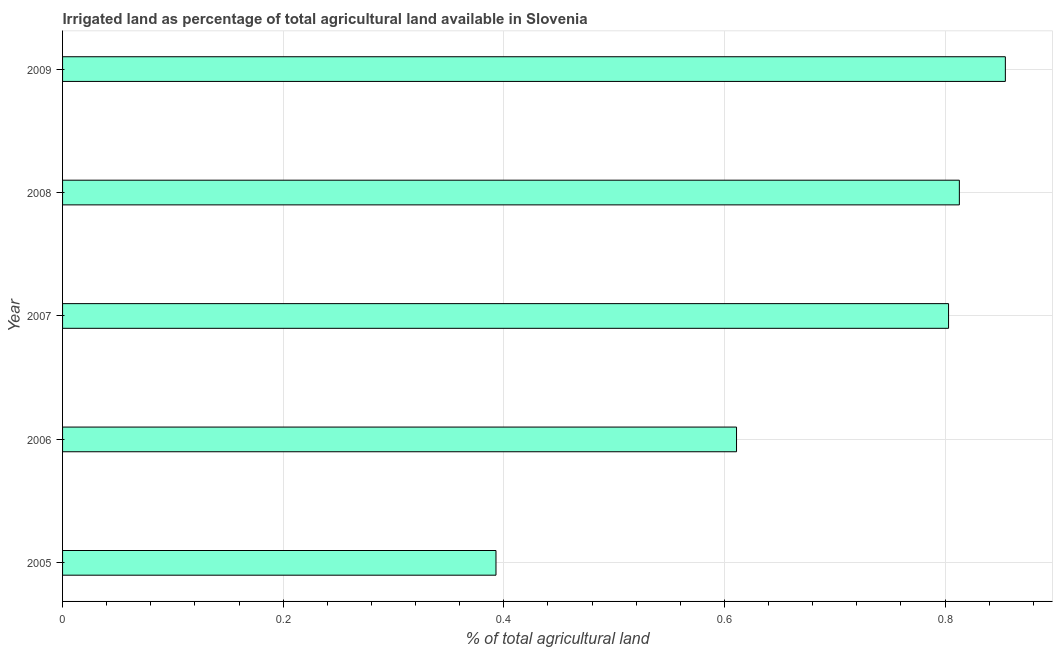Does the graph contain grids?
Your answer should be very brief. Yes. What is the title of the graph?
Offer a terse response. Irrigated land as percentage of total agricultural land available in Slovenia. What is the label or title of the X-axis?
Keep it short and to the point. % of total agricultural land. What is the percentage of agricultural irrigated land in 2009?
Your response must be concise. 0.85. Across all years, what is the maximum percentage of agricultural irrigated land?
Ensure brevity in your answer.  0.85. Across all years, what is the minimum percentage of agricultural irrigated land?
Make the answer very short. 0.39. In which year was the percentage of agricultural irrigated land minimum?
Offer a terse response. 2005. What is the sum of the percentage of agricultural irrigated land?
Your response must be concise. 3.47. What is the difference between the percentage of agricultural irrigated land in 2007 and 2009?
Your answer should be compact. -0.05. What is the average percentage of agricultural irrigated land per year?
Offer a terse response. 0.69. What is the median percentage of agricultural irrigated land?
Your answer should be compact. 0.8. In how many years, is the percentage of agricultural irrigated land greater than 0.48 %?
Provide a succinct answer. 4. Do a majority of the years between 2007 and 2005 (inclusive) have percentage of agricultural irrigated land greater than 0.32 %?
Offer a very short reply. Yes. Is the difference between the percentage of agricultural irrigated land in 2007 and 2009 greater than the difference between any two years?
Provide a succinct answer. No. What is the difference between the highest and the second highest percentage of agricultural irrigated land?
Keep it short and to the point. 0.04. What is the difference between the highest and the lowest percentage of agricultural irrigated land?
Make the answer very short. 0.46. In how many years, is the percentage of agricultural irrigated land greater than the average percentage of agricultural irrigated land taken over all years?
Offer a terse response. 3. How many years are there in the graph?
Offer a very short reply. 5. What is the % of total agricultural land in 2005?
Ensure brevity in your answer.  0.39. What is the % of total agricultural land of 2006?
Provide a short and direct response. 0.61. What is the % of total agricultural land in 2007?
Give a very brief answer. 0.8. What is the % of total agricultural land in 2008?
Your answer should be very brief. 0.81. What is the % of total agricultural land of 2009?
Your answer should be compact. 0.85. What is the difference between the % of total agricultural land in 2005 and 2006?
Your answer should be very brief. -0.22. What is the difference between the % of total agricultural land in 2005 and 2007?
Keep it short and to the point. -0.41. What is the difference between the % of total agricultural land in 2005 and 2008?
Provide a short and direct response. -0.42. What is the difference between the % of total agricultural land in 2005 and 2009?
Your answer should be compact. -0.46. What is the difference between the % of total agricultural land in 2006 and 2007?
Give a very brief answer. -0.19. What is the difference between the % of total agricultural land in 2006 and 2008?
Keep it short and to the point. -0.2. What is the difference between the % of total agricultural land in 2006 and 2009?
Your response must be concise. -0.24. What is the difference between the % of total agricultural land in 2007 and 2008?
Your answer should be compact. -0.01. What is the difference between the % of total agricultural land in 2007 and 2009?
Make the answer very short. -0.05. What is the difference between the % of total agricultural land in 2008 and 2009?
Your answer should be very brief. -0.04. What is the ratio of the % of total agricultural land in 2005 to that in 2006?
Provide a short and direct response. 0.64. What is the ratio of the % of total agricultural land in 2005 to that in 2007?
Ensure brevity in your answer.  0.49. What is the ratio of the % of total agricultural land in 2005 to that in 2008?
Provide a succinct answer. 0.48. What is the ratio of the % of total agricultural land in 2005 to that in 2009?
Provide a short and direct response. 0.46. What is the ratio of the % of total agricultural land in 2006 to that in 2007?
Your answer should be very brief. 0.76. What is the ratio of the % of total agricultural land in 2006 to that in 2008?
Keep it short and to the point. 0.75. What is the ratio of the % of total agricultural land in 2006 to that in 2009?
Your response must be concise. 0.71. What is the ratio of the % of total agricultural land in 2007 to that in 2008?
Your answer should be compact. 0.99. What is the ratio of the % of total agricultural land in 2008 to that in 2009?
Your answer should be compact. 0.95. 